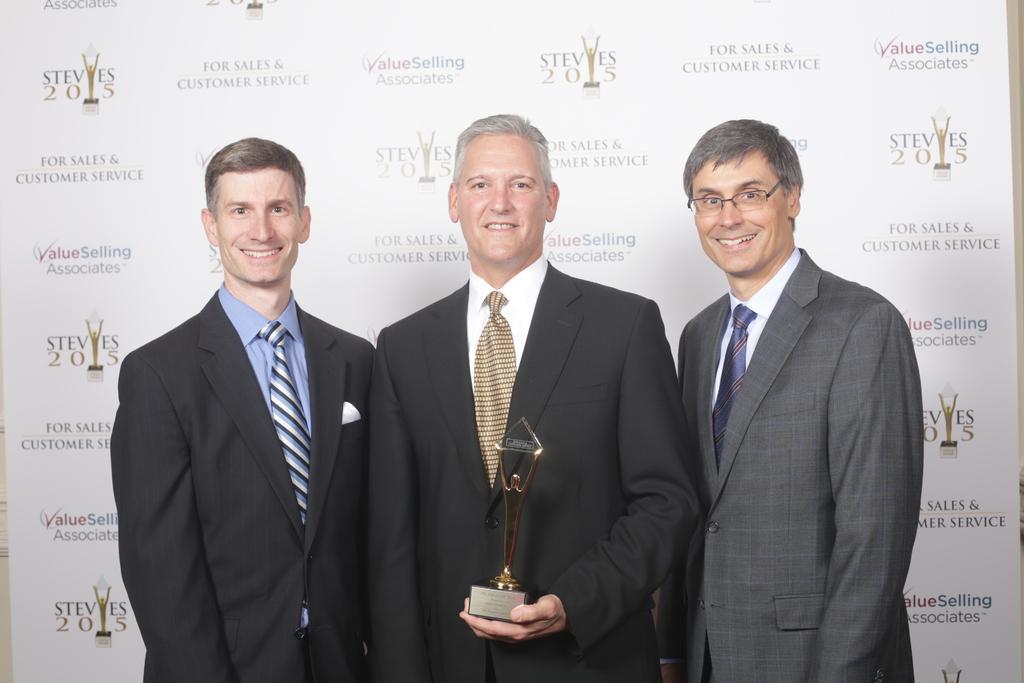Could you give a brief overview of what you see in this image? In this image we can see three persons standing and smiling, among them, the middle one is holding an object, in the background we can see a poster with text. 